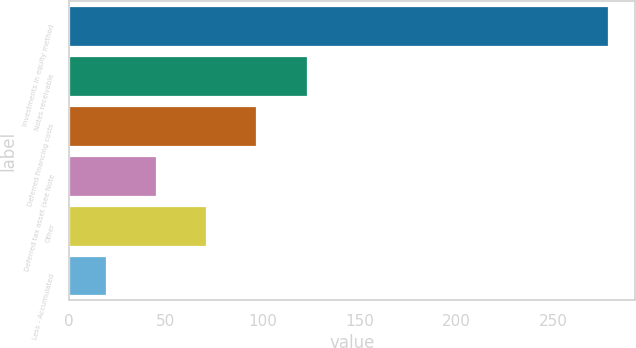Convert chart to OTSL. <chart><loc_0><loc_0><loc_500><loc_500><bar_chart><fcel>Investments in equity method<fcel>Notes receivable<fcel>Deferred financing costs<fcel>Deferred tax asset (see Note<fcel>Other<fcel>Less - Accumulated<nl><fcel>278.5<fcel>122.86<fcel>96.92<fcel>45.04<fcel>70.98<fcel>19.1<nl></chart> 